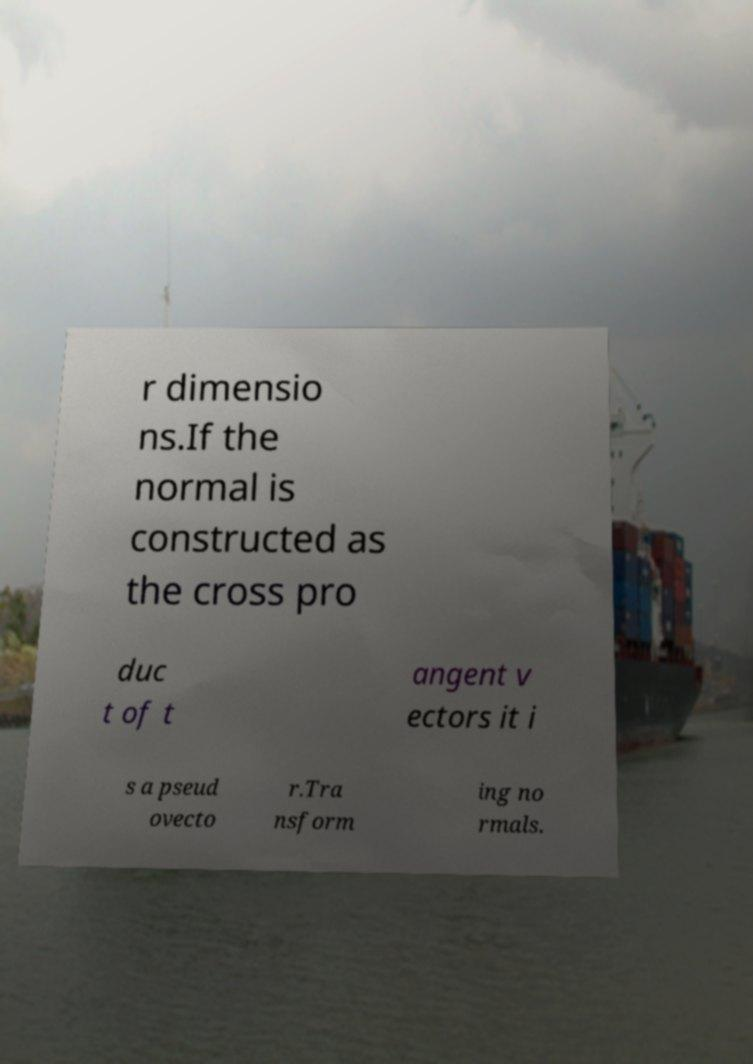Could you assist in decoding the text presented in this image and type it out clearly? r dimensio ns.If the normal is constructed as the cross pro duc t of t angent v ectors it i s a pseud ovecto r.Tra nsform ing no rmals. 